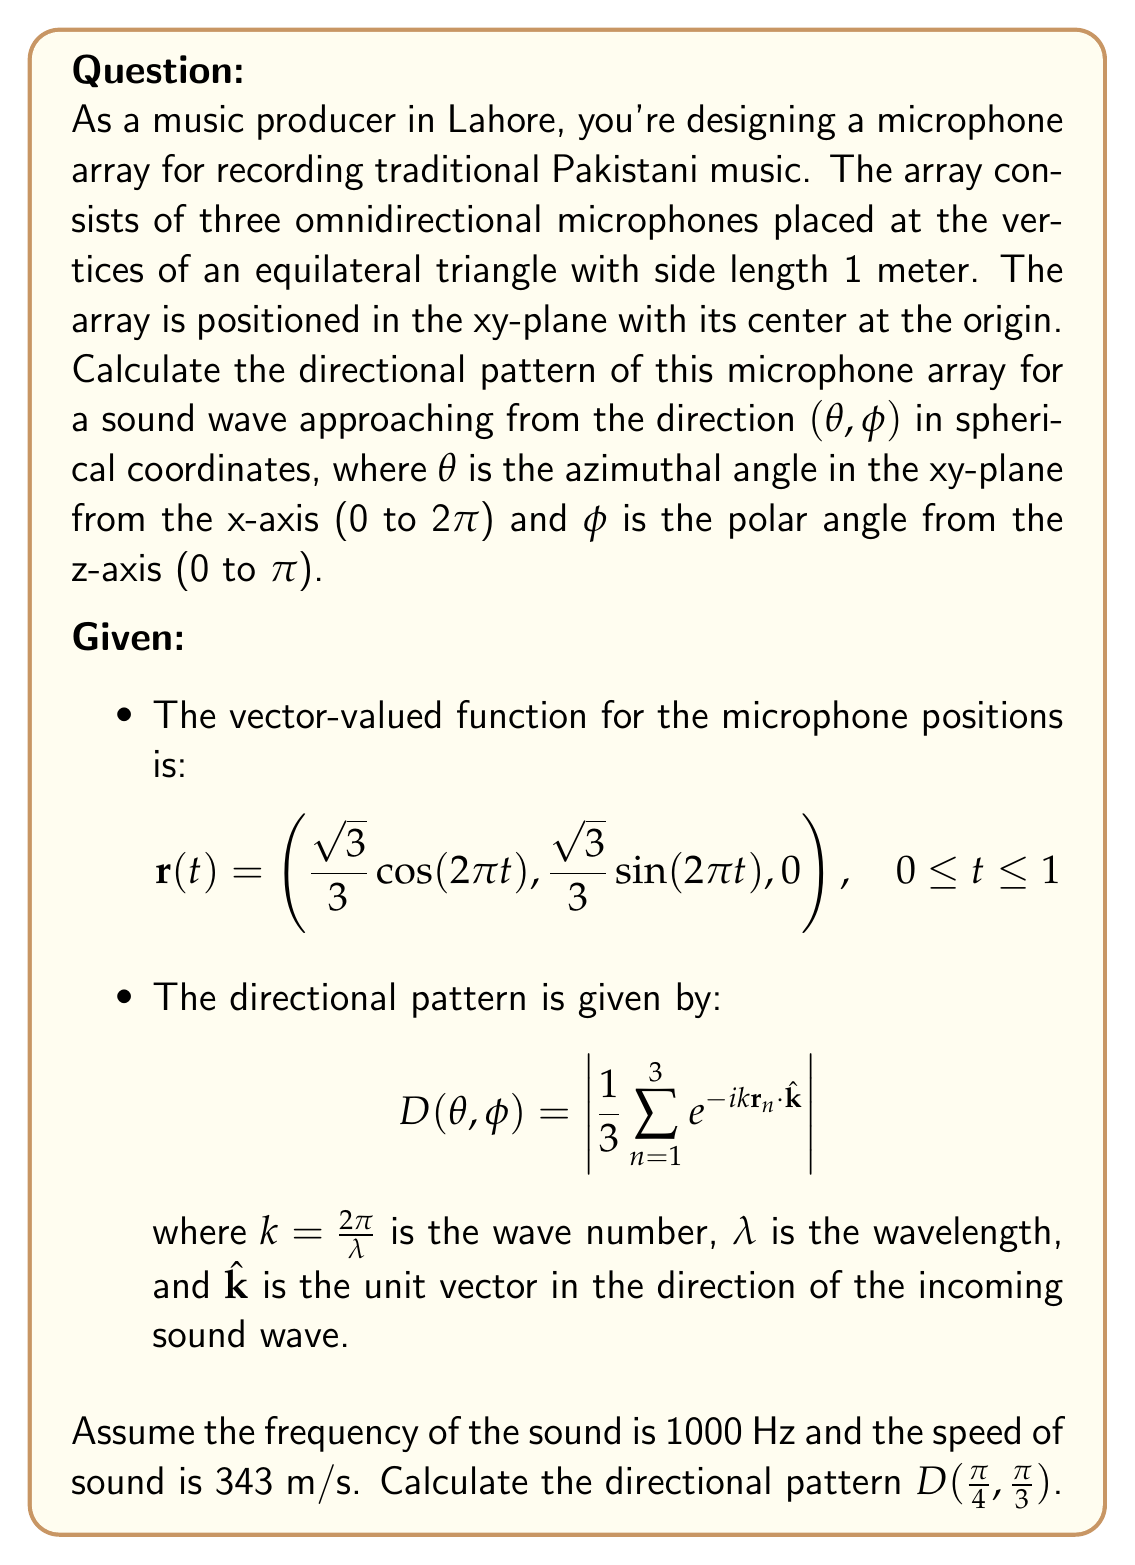Solve this math problem. Let's approach this step-by-step:

1) First, we need to calculate the wavelength $\lambda$:
   $$\lambda = \frac{c}{f} = \frac{343 \text{ m/s}}{1000 \text{ Hz}} = 0.343 \text{ m}$$

2) Now we can calculate the wave number $k$:
   $$k = \frac{2\pi}{\lambda} = \frac{2\pi}{0.343} \approx 18.32 \text{ m}^{-1}$$

3) Next, we need to find the positions of the three microphones. We can use the vector-valued function $\mathbf{r}(t)$ with $t = 0, \frac{1}{3}, \frac{2}{3}$:
   
   $$\mathbf{r}_1 = \mathbf{r}(0) = (\frac{\sqrt{3}}{3}, 0, 0)$$
   $$\mathbf{r}_2 = \mathbf{r}(\frac{1}{3}) = (-\frac{\sqrt{3}}{6}, \frac{1}{2}, 0)$$
   $$\mathbf{r}_3 = \mathbf{r}(\frac{2}{3}) = (-\frac{\sqrt{3}}{6}, -\frac{1}{2}, 0)$$

4) The unit vector $\hat{\mathbf{k}}$ in the direction of the incoming sound wave is:
   $$\hat{\mathbf{k}} = (\sin\phi \cos\theta, \sin\phi \sin\theta, \cos\phi)$$
   
   For $\theta = \frac{\pi}{4}$ and $\phi = \frac{\pi}{3}$:
   $$\hat{\mathbf{k}} = (\frac{\sqrt{2}}{2} \cdot \frac{\sqrt{3}}{2}, \frac{\sqrt{2}}{2} \cdot \frac{\sqrt{3}}{2}, \frac{1}{2})$$

5) Now we can calculate $\mathbf{r}_n \cdot \hat{\mathbf{k}}$ for each microphone:
   
   $$\mathbf{r}_1 \cdot \hat{\mathbf{k}} = \frac{\sqrt{3}}{3} \cdot \frac{\sqrt{2}}{2} \cdot \frac{\sqrt{3}}{2} = \frac{1}{2}$$
   
   $$\mathbf{r}_2 \cdot \hat{\mathbf{k}} = -\frac{\sqrt{3}}{6} \cdot \frac{\sqrt{2}}{2} \cdot \frac{\sqrt{3}}{2} + \frac{1}{2} \cdot \frac{\sqrt{2}}{2} \cdot \frac{\sqrt{3}}{2} = \frac{\sqrt{6}}{12}$$
   
   $$\mathbf{r}_3 \cdot \hat{\mathbf{k}} = -\frac{\sqrt{3}}{6} \cdot \frac{\sqrt{2}}{2} \cdot \frac{\sqrt{3}}{2} - \frac{1}{2} \cdot \frac{\sqrt{2}}{2} \cdot \frac{\sqrt{3}}{2} = -\frac{5\sqrt{6}}{12}$$

6) Now we can calculate the directional pattern:

   $$D(\frac{\pi}{4}, \frac{\pi}{3}) = \left|\frac{1}{3}(e^{-ik\cdot\frac{1}{2}} + e^{-ik\cdot\frac{\sqrt{6}}{12}} + e^{ik\cdot\frac{5\sqrt{6}}{12}})\right|$$

7) Substituting the value of $k$:

   $$D(\frac{\pi}{4}, \frac{\pi}{3}) = \left|\frac{1}{3}(e^{-i\cdot18.32\cdot\frac{1}{2}} + e^{-i\cdot18.32\cdot\frac{\sqrt{6}}{12}} + e^{i\cdot18.32\cdot\frac{5\sqrt{6}}{12}})\right|$$

8) Calculating this complex number and taking its magnitude:

   $$D(\frac{\pi}{4}, \frac{\pi}{3}) \approx 0.7126$$
Answer: The directional pattern of the microphone array for a sound wave approaching from the direction $(\frac{\pi}{4}, \frac{\pi}{3})$ is approximately 0.7126. 